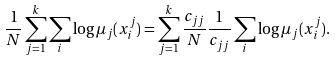<formula> <loc_0><loc_0><loc_500><loc_500>\frac { 1 } { N } \sum _ { j = 1 } ^ { k } \sum _ { i } \log \mu _ { j } ( x _ { i } ^ { j } ) = \sum _ { j = 1 } ^ { k } \frac { c _ { j j } } { N } \frac { 1 } { c _ { j j } } \sum _ { i } \log \mu _ { j } ( x _ { i } ^ { j } ) .</formula> 